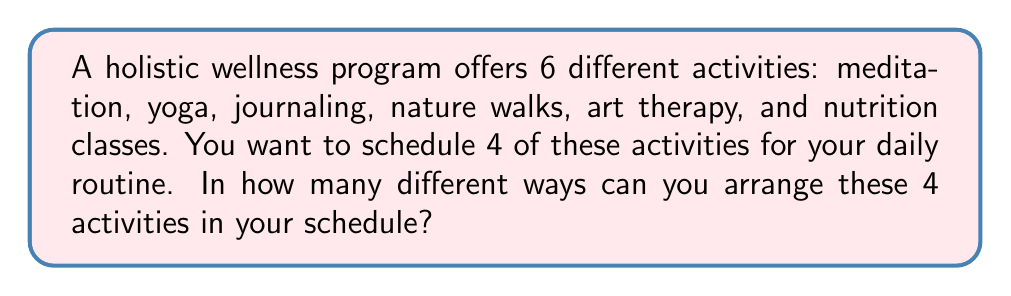Teach me how to tackle this problem. Let's approach this step-by-step:

1) First, we need to choose 4 activities out of the 6 available. This is a combination problem.

2) The number of ways to choose 4 items from 6 is given by the combination formula:

   $$\binom{6}{4} = \frac{6!}{4!(6-4)!} = \frac{6!}{4!2!}$$

3) Calculating this:
   $$\frac{6 * 5 * 4!}{4! * 2 * 1} = \frac{30}{2} = 15$$

4) So there are 15 ways to choose 4 activities out of 6.

5) Now, for each of these 15 choices, we need to arrange the 4 chosen activities in order. This is a permutation of 4 items.

6) The number of ways to arrange 4 items is simply 4!, which is:
   $$4! = 4 * 3 * 2 * 1 = 24$$

7) By the multiplication principle, the total number of ways to choose and arrange 4 activities out of 6 is:

   $$15 * 24 = 360$$

Therefore, there are 360 different ways to arrange 4 activities in your daily schedule.
Answer: 360 